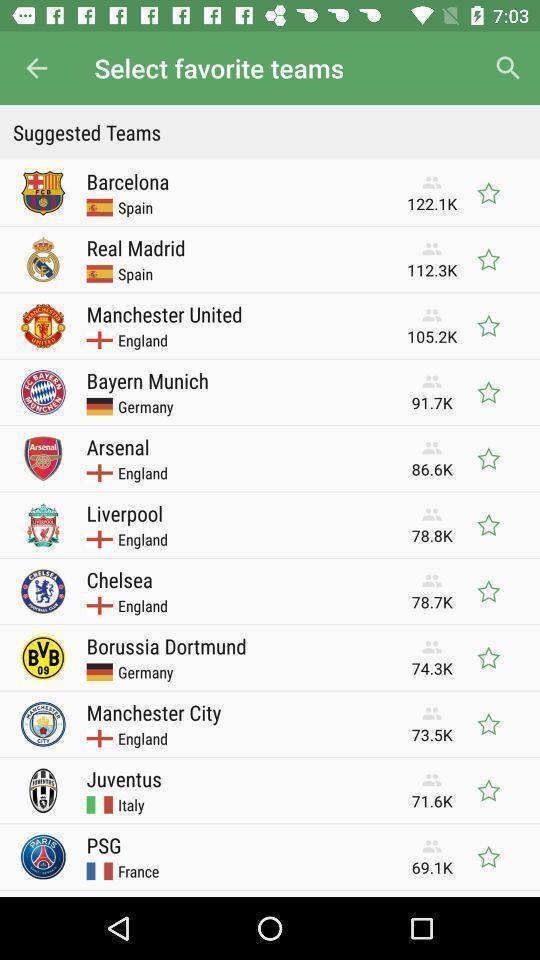Provide a detailed account of this screenshot. Screen shows to select favorite teams. 